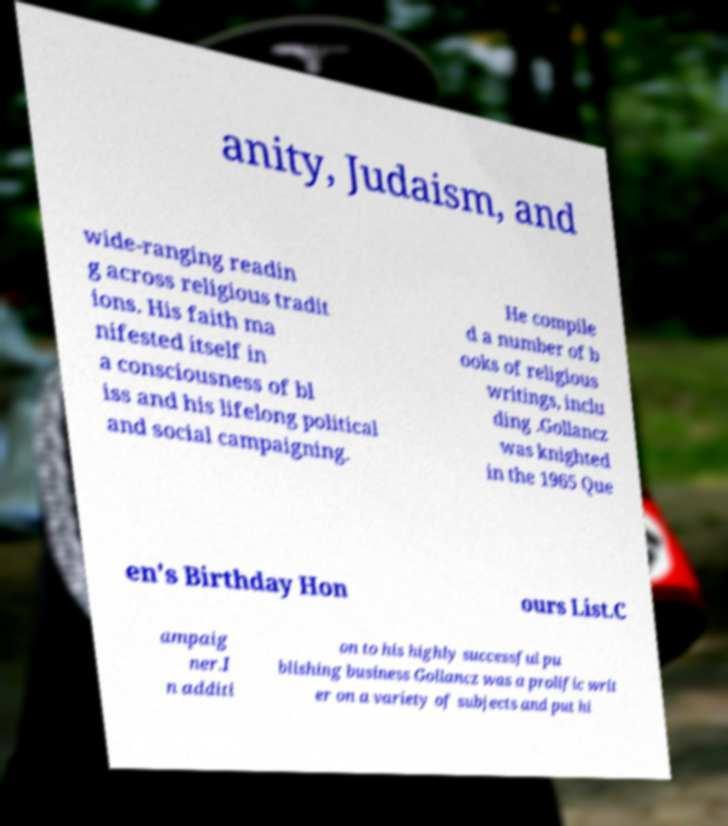Please read and relay the text visible in this image. What does it say? anity, Judaism, and wide-ranging readin g across religious tradit ions. His faith ma nifested itself in a consciousness of bl iss and his lifelong political and social campaigning. He compile d a number of b ooks of religious writings, inclu ding .Gollancz was knighted in the 1965 Que en's Birthday Hon ours List.C ampaig ner.I n additi on to his highly successful pu blishing business Gollancz was a prolific writ er on a variety of subjects and put hi 